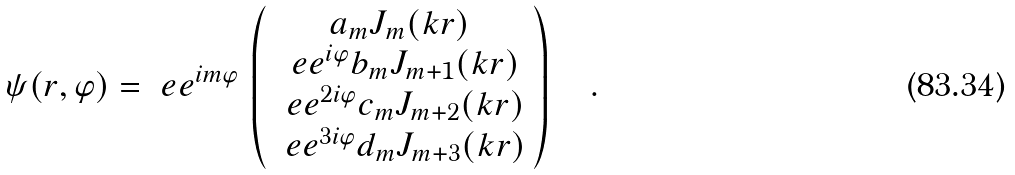Convert formula to latex. <formula><loc_0><loc_0><loc_500><loc_500>\psi ( r , \varphi ) = \ e e ^ { i m \varphi } \, \left ( \begin{array} { c } a _ { m } J _ { m } ( k r ) \\ \ e e ^ { i \varphi } b _ { m } J _ { m + 1 } ( k r ) \\ \ e e ^ { 2 i \varphi } c _ { m } J _ { m + 2 } ( k r ) \\ \ e e ^ { 3 i \varphi } d _ { m } J _ { m + 3 } ( k r ) \end{array} \right ) \quad .</formula> 